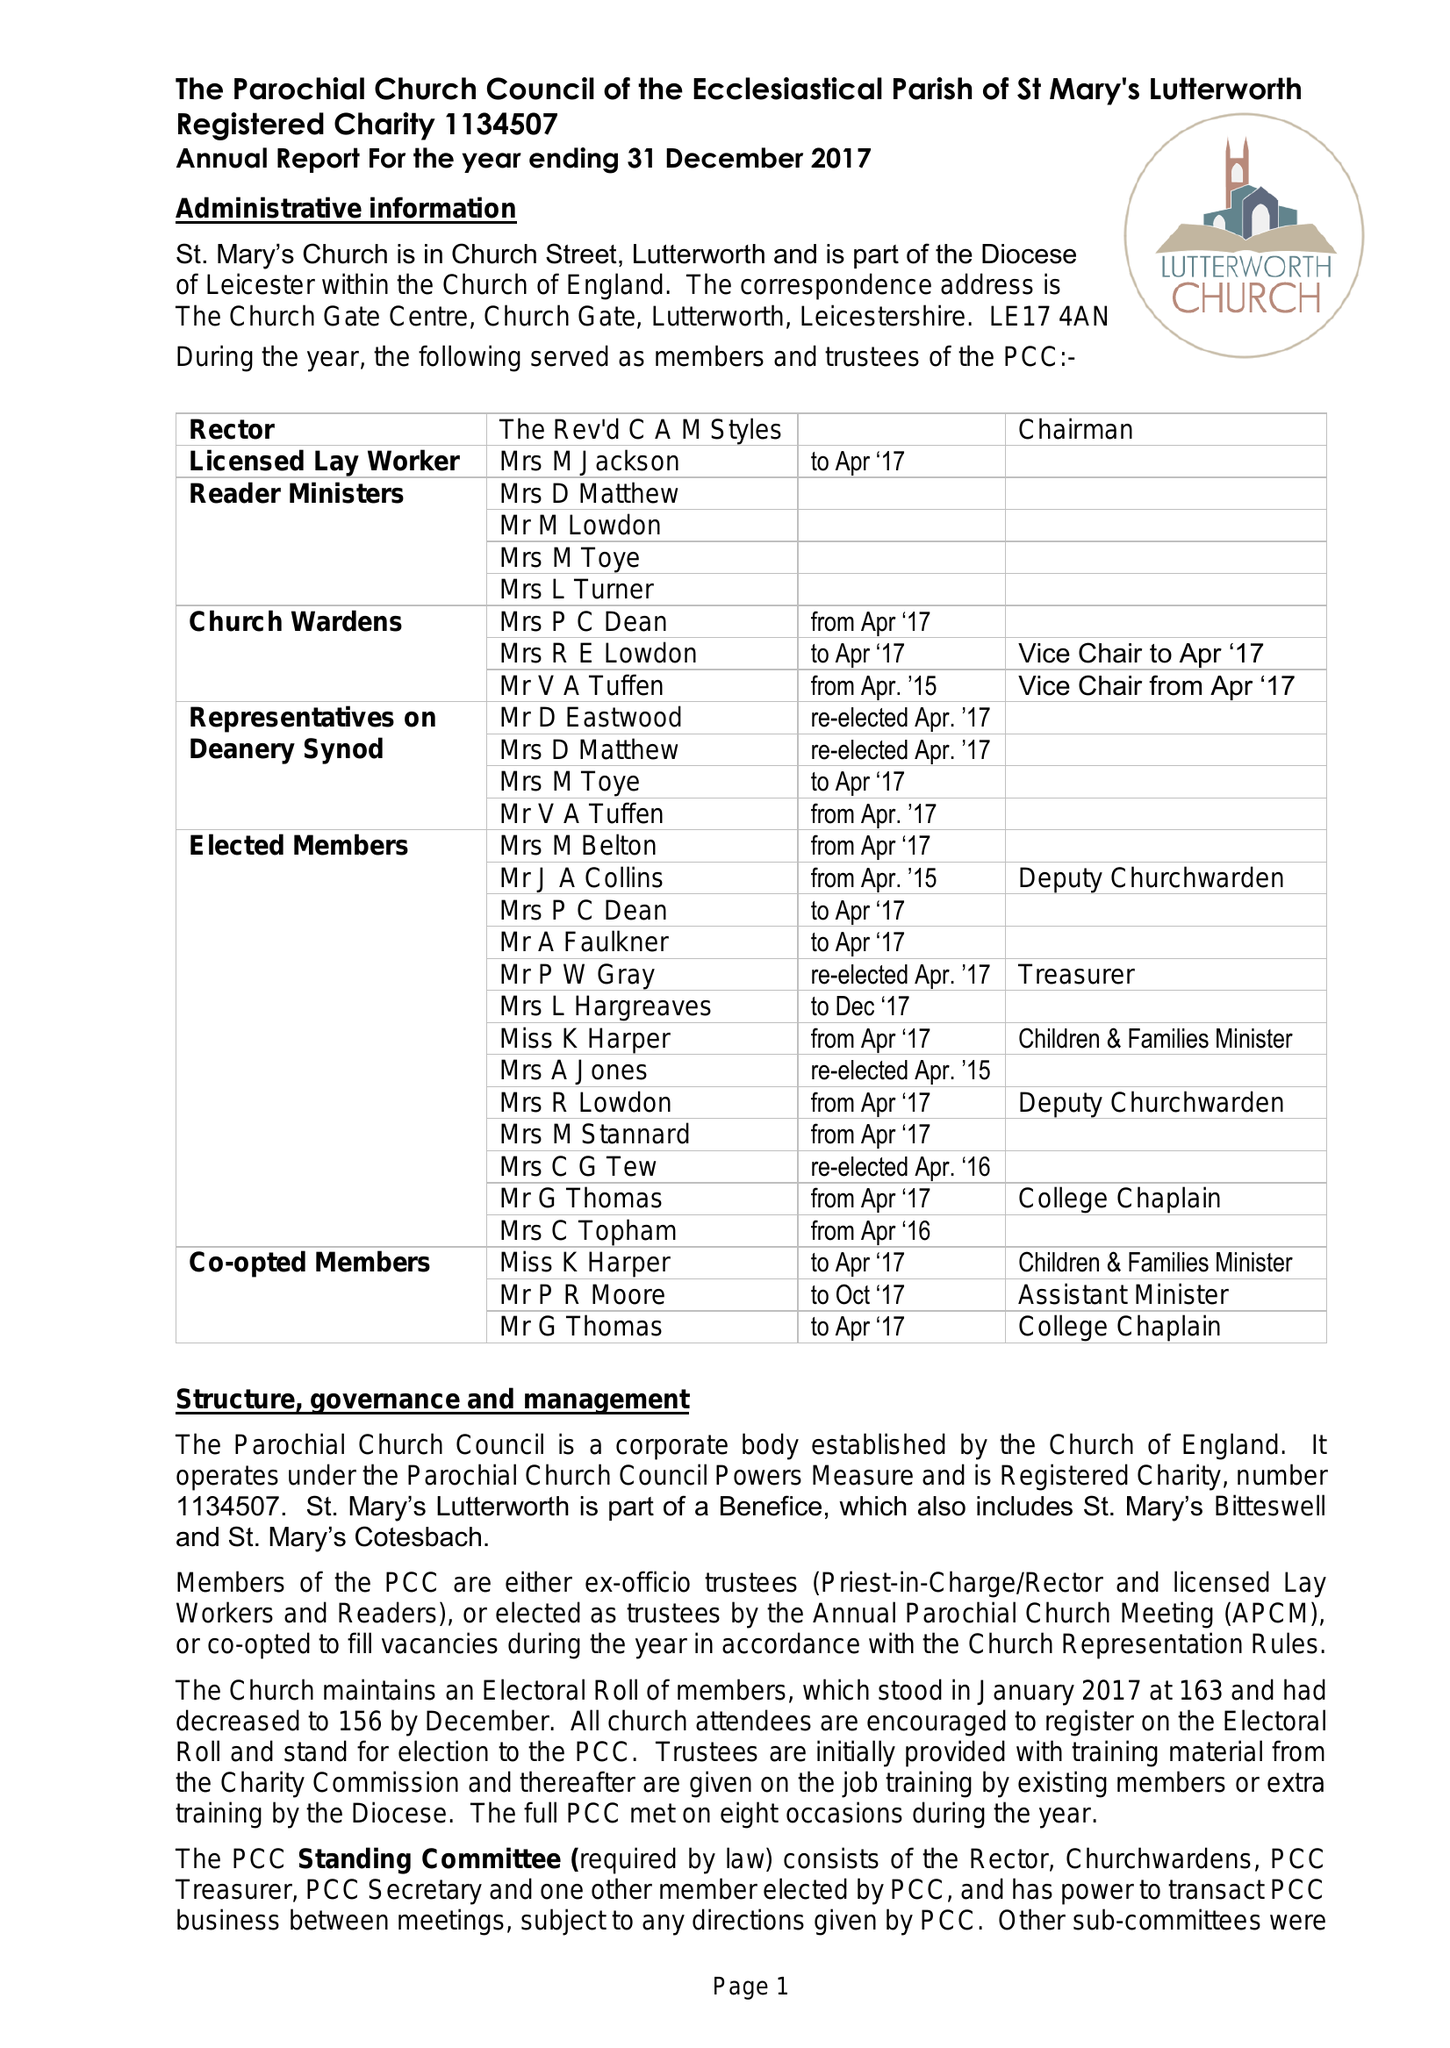What is the value for the address__postcode?
Answer the question using a single word or phrase. LE17 4AN 